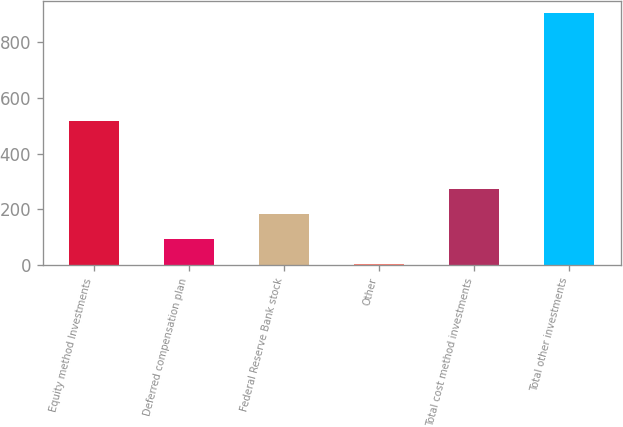Convert chart to OTSL. <chart><loc_0><loc_0><loc_500><loc_500><bar_chart><fcel>Equity method Investments<fcel>Deferred compensation plan<fcel>Federal Reserve Bank stock<fcel>Other<fcel>Total cost method investments<fcel>Total other investments<nl><fcel>518<fcel>93.9<fcel>183.8<fcel>4<fcel>273.7<fcel>903<nl></chart> 